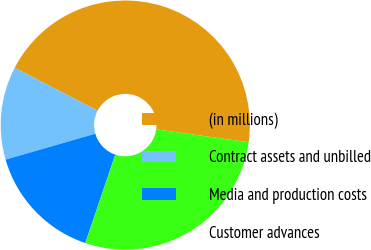<chart> <loc_0><loc_0><loc_500><loc_500><pie_chart><fcel>(in millions)<fcel>Contract assets and unbilled<fcel>Media and production costs<fcel>Customer advances<nl><fcel>44.59%<fcel>12.08%<fcel>15.33%<fcel>28.0%<nl></chart> 